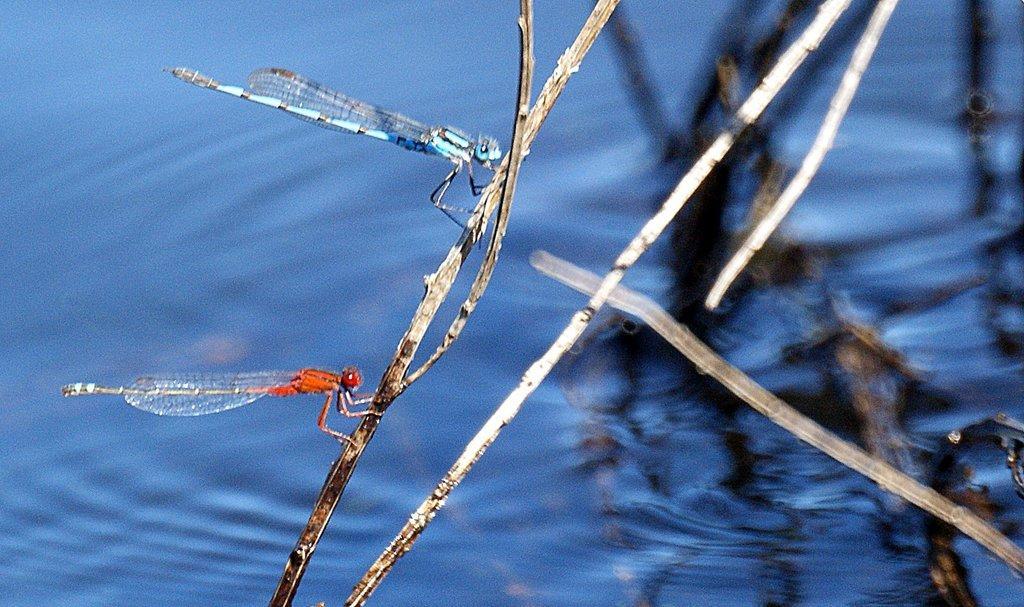Could you give a brief overview of what you see in this image? In the center of the image we can see the dragonflies are present on a stick. In the background of the image we can see the water and sticks. 